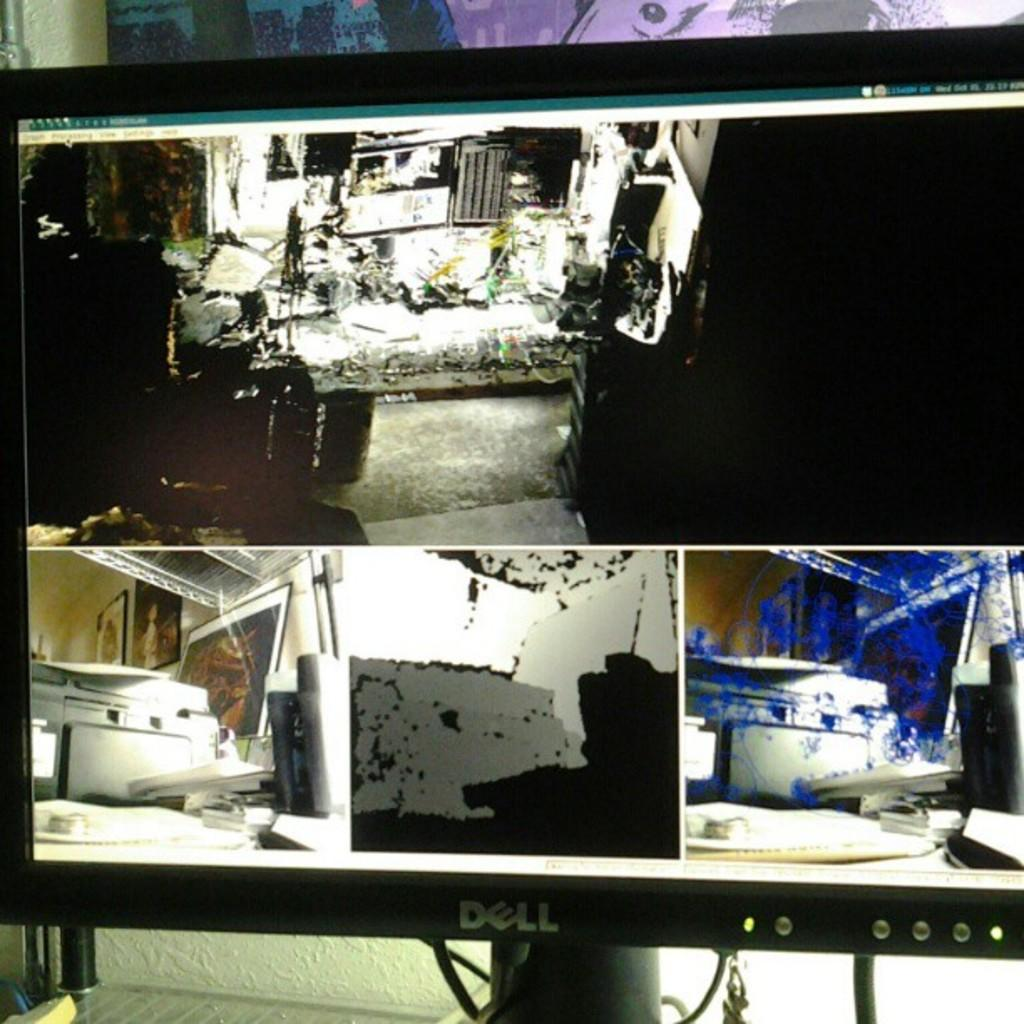Provide a one-sentence caption for the provided image. A Dell computer shows a screen full of mechanical photos. 